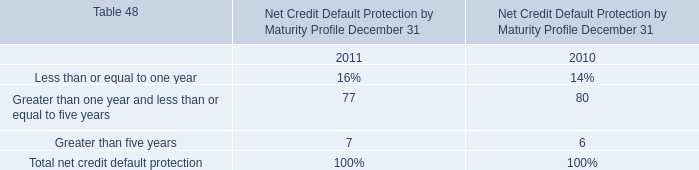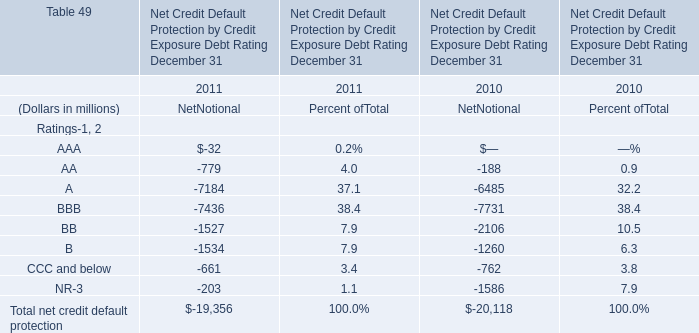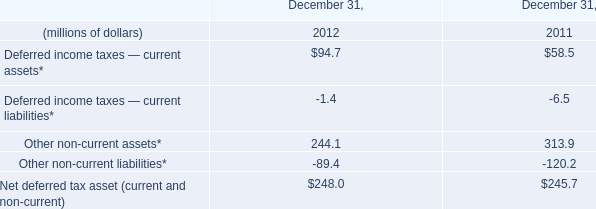What's the current growth rate of Total net credit default protection? 
Computations: ((-19356 + 20118) / -20118)
Answer: -0.03788. 